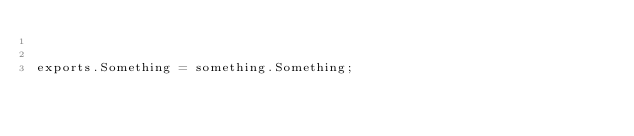<code> <loc_0><loc_0><loc_500><loc_500><_JavaScript_>

exports.Something = something.Something;
</code> 